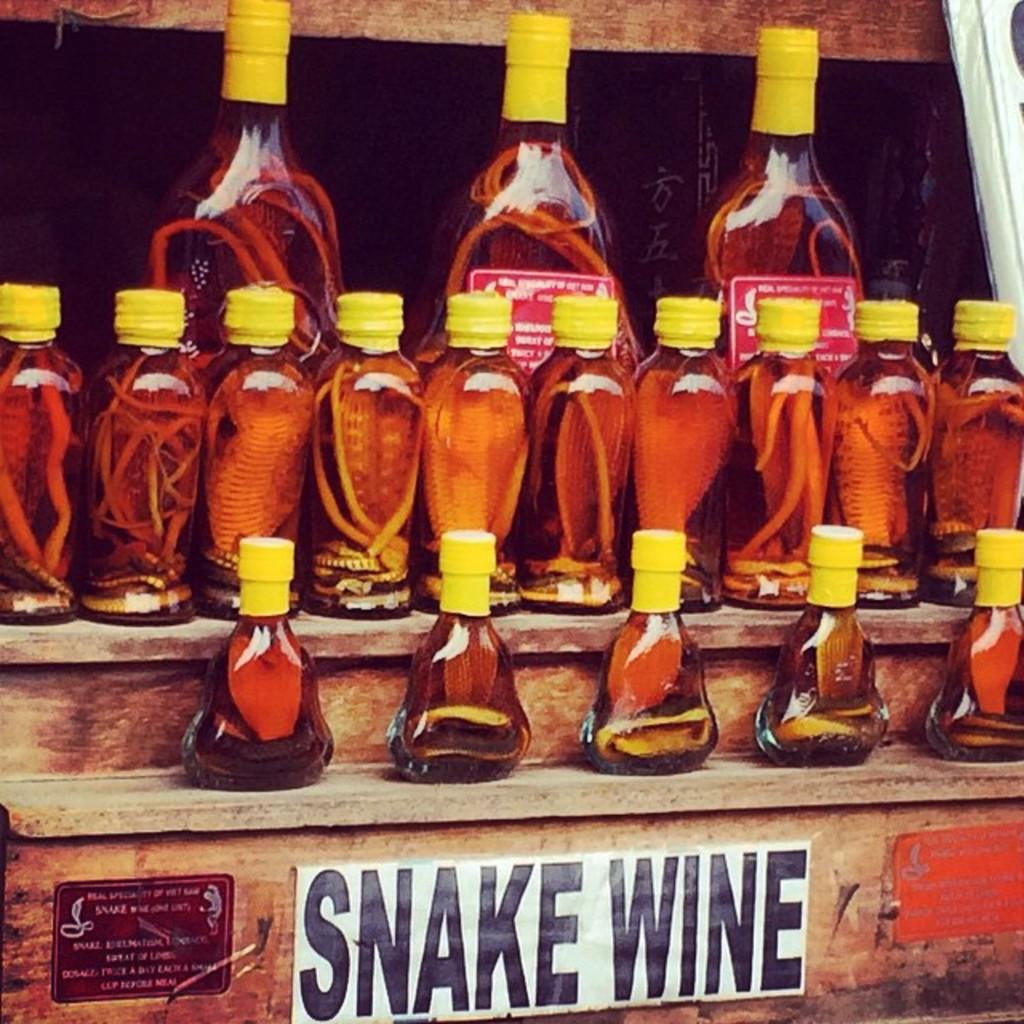Provide a one-sentence caption for the provided image. A bunch of irregular bottles full of Snake Wine. 